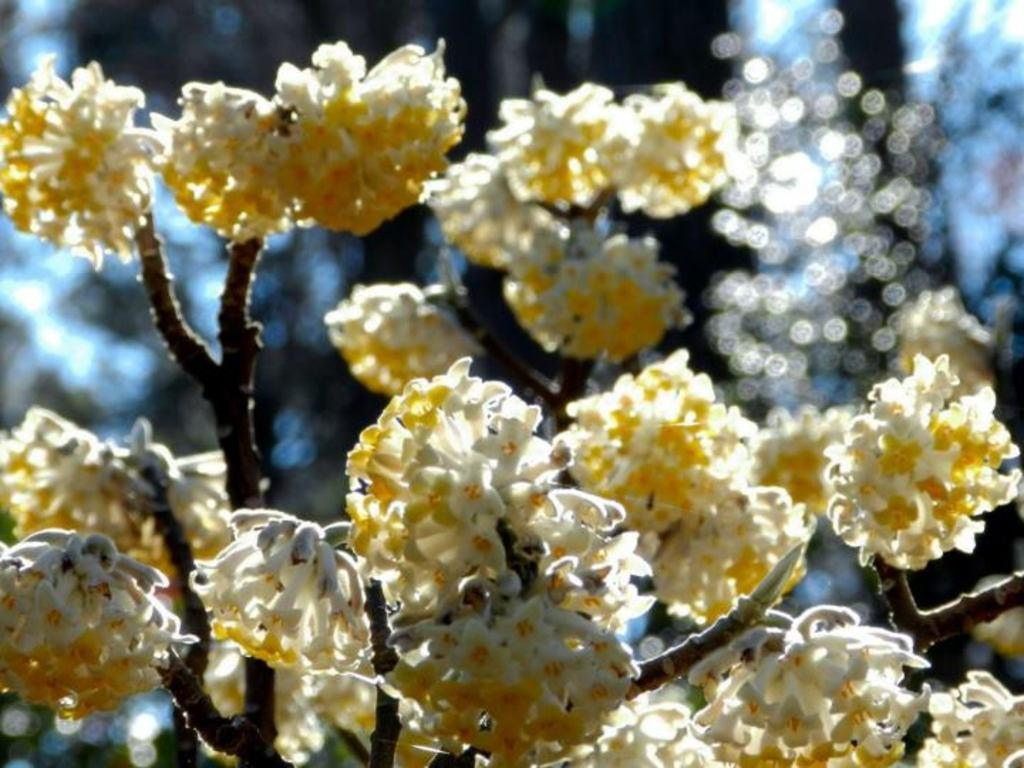What type of plants can be seen in the image? There are flowers in the image. What part of the flowers is visible in the image? The flowers have branches in the image. What type of shock can be seen in the image? There is no shock present in the image; it features flowers with branches. Can you tell me who the father is in the image? There is no person, let alone a father, present in the image; it features flowers with branches. 